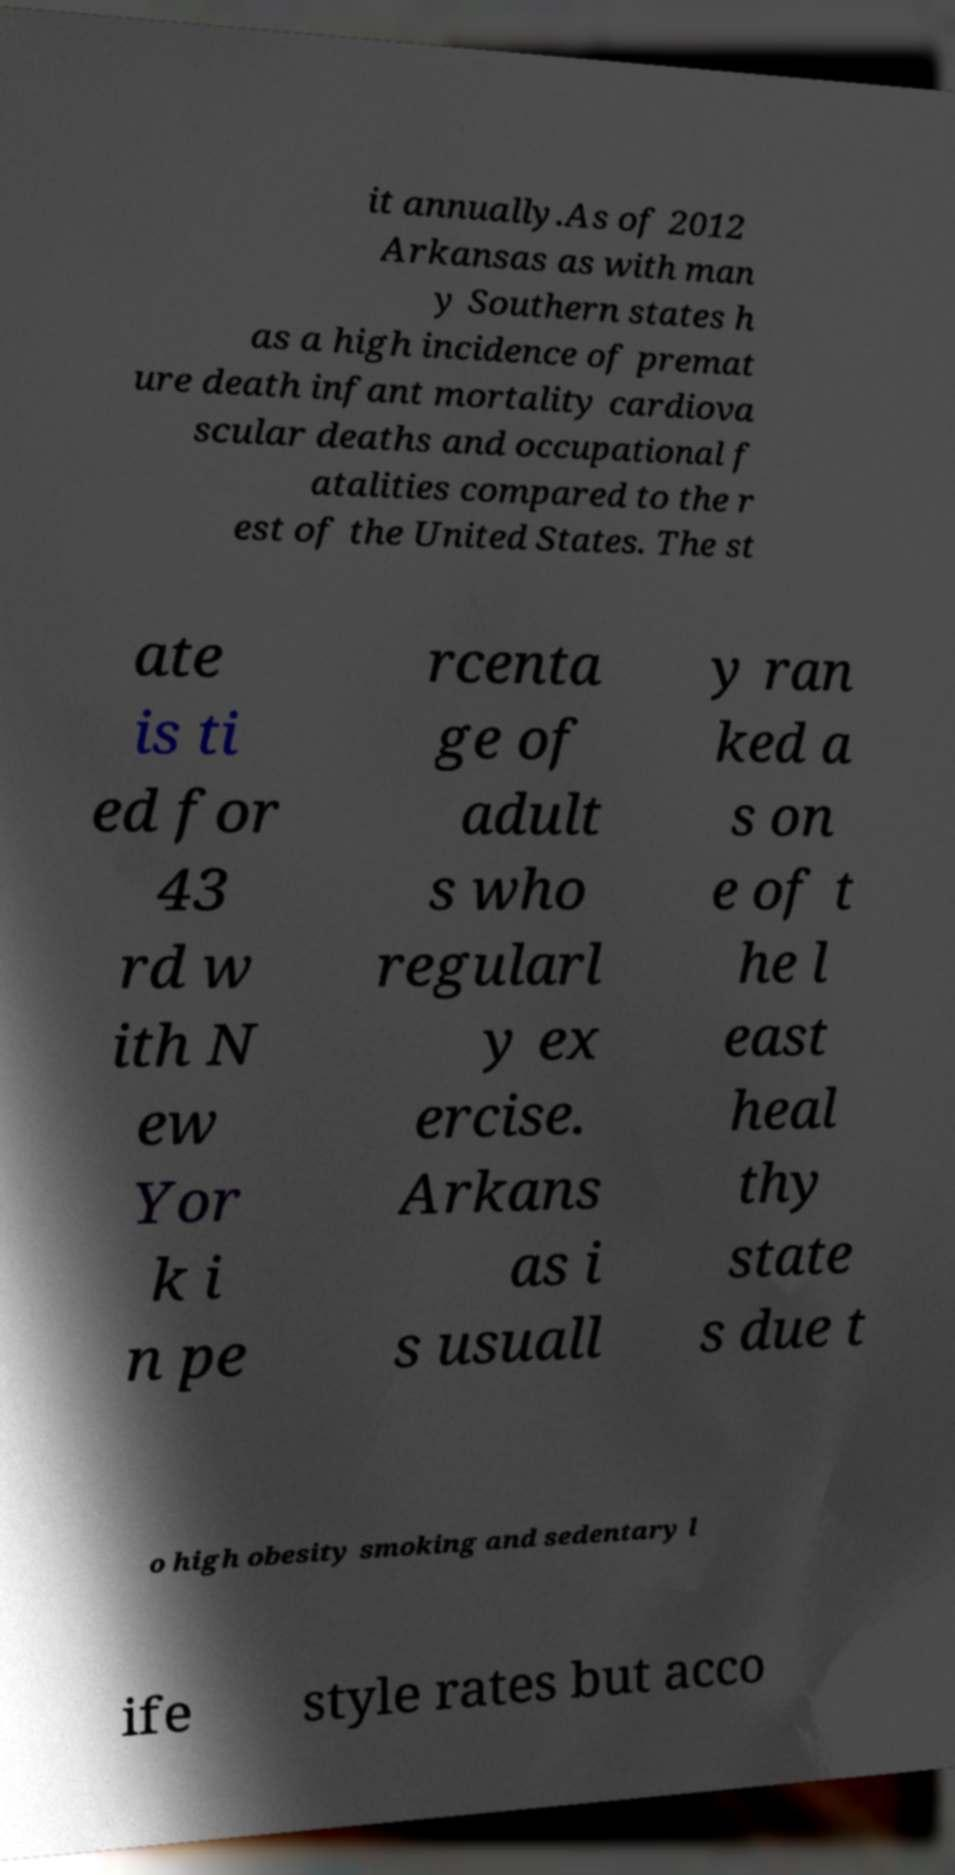I need the written content from this picture converted into text. Can you do that? it annually.As of 2012 Arkansas as with man y Southern states h as a high incidence of premat ure death infant mortality cardiova scular deaths and occupational f atalities compared to the r est of the United States. The st ate is ti ed for 43 rd w ith N ew Yor k i n pe rcenta ge of adult s who regularl y ex ercise. Arkans as i s usuall y ran ked a s on e of t he l east heal thy state s due t o high obesity smoking and sedentary l ife style rates but acco 